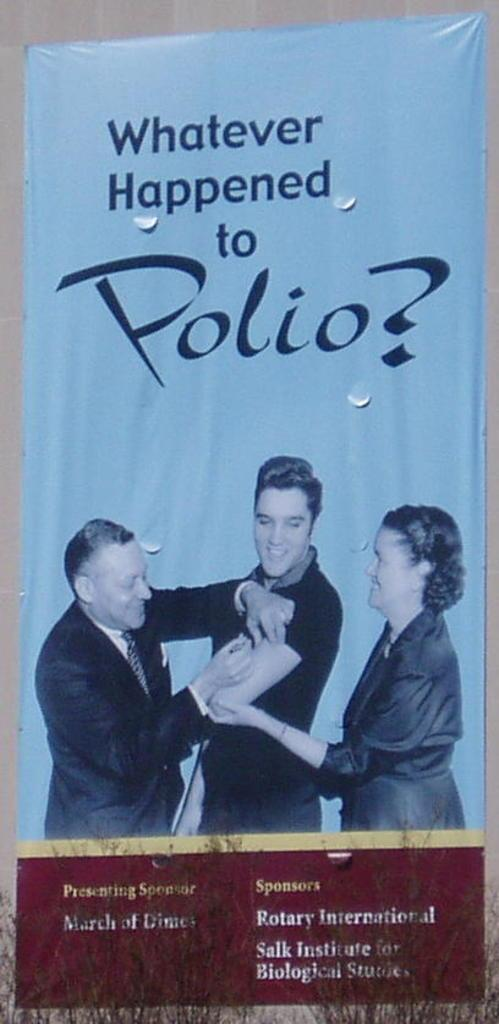<image>
Write a terse but informative summary of the picture. Elvis Presley is featured on an advertisement for the fight against polio. 